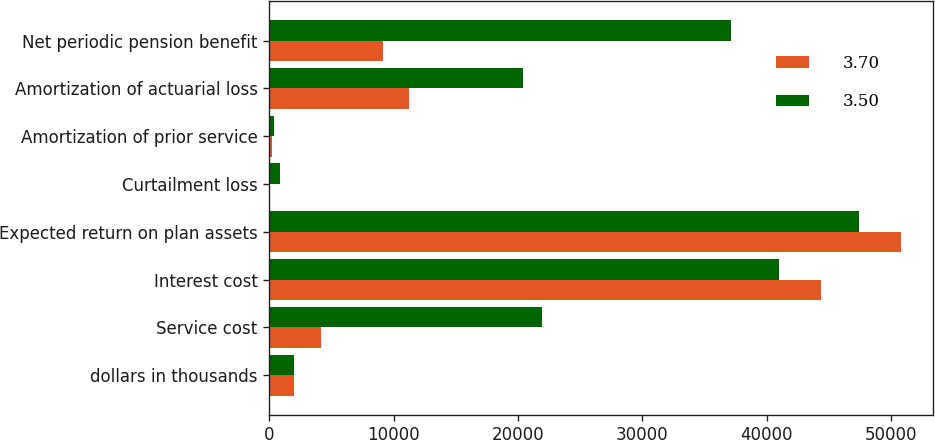Convert chart to OTSL. <chart><loc_0><loc_0><loc_500><loc_500><stacked_bar_chart><ecel><fcel>dollars in thousands<fcel>Service cost<fcel>Interest cost<fcel>Expected return on plan assets<fcel>Curtailment loss<fcel>Amortization of prior service<fcel>Amortization of actuarial loss<fcel>Net periodic pension benefit<nl><fcel>3.7<fcel>2014<fcel>4157<fcel>44392<fcel>50802<fcel>0<fcel>188<fcel>11221<fcel>9156<nl><fcel>3.5<fcel>2013<fcel>21904<fcel>40995<fcel>47425<fcel>855<fcel>339<fcel>20429<fcel>37097<nl></chart> 